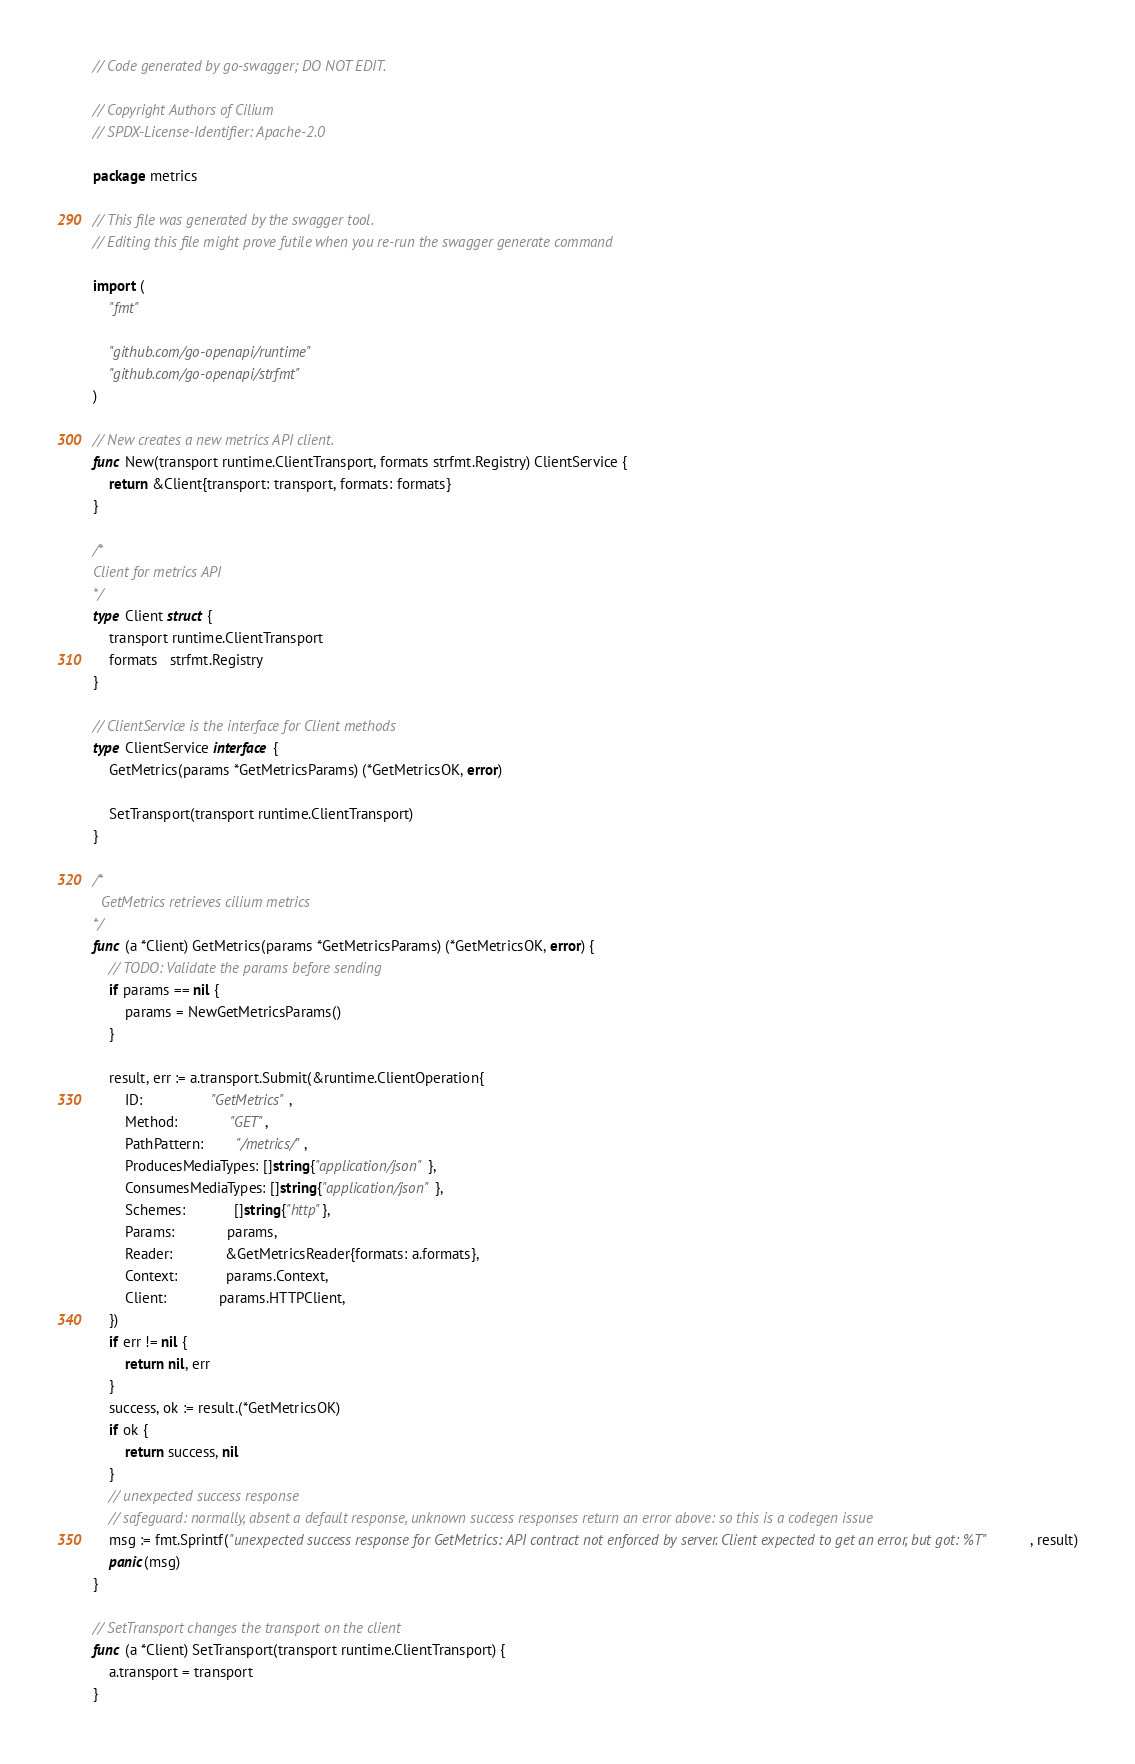Convert code to text. <code><loc_0><loc_0><loc_500><loc_500><_Go_>// Code generated by go-swagger; DO NOT EDIT.

// Copyright Authors of Cilium
// SPDX-License-Identifier: Apache-2.0

package metrics

// This file was generated by the swagger tool.
// Editing this file might prove futile when you re-run the swagger generate command

import (
	"fmt"

	"github.com/go-openapi/runtime"
	"github.com/go-openapi/strfmt"
)

// New creates a new metrics API client.
func New(transport runtime.ClientTransport, formats strfmt.Registry) ClientService {
	return &Client{transport: transport, formats: formats}
}

/*
Client for metrics API
*/
type Client struct {
	transport runtime.ClientTransport
	formats   strfmt.Registry
}

// ClientService is the interface for Client methods
type ClientService interface {
	GetMetrics(params *GetMetricsParams) (*GetMetricsOK, error)

	SetTransport(transport runtime.ClientTransport)
}

/*
  GetMetrics retrieves cilium metrics
*/
func (a *Client) GetMetrics(params *GetMetricsParams) (*GetMetricsOK, error) {
	// TODO: Validate the params before sending
	if params == nil {
		params = NewGetMetricsParams()
	}

	result, err := a.transport.Submit(&runtime.ClientOperation{
		ID:                 "GetMetrics",
		Method:             "GET",
		PathPattern:        "/metrics/",
		ProducesMediaTypes: []string{"application/json"},
		ConsumesMediaTypes: []string{"application/json"},
		Schemes:            []string{"http"},
		Params:             params,
		Reader:             &GetMetricsReader{formats: a.formats},
		Context:            params.Context,
		Client:             params.HTTPClient,
	})
	if err != nil {
		return nil, err
	}
	success, ok := result.(*GetMetricsOK)
	if ok {
		return success, nil
	}
	// unexpected success response
	// safeguard: normally, absent a default response, unknown success responses return an error above: so this is a codegen issue
	msg := fmt.Sprintf("unexpected success response for GetMetrics: API contract not enforced by server. Client expected to get an error, but got: %T", result)
	panic(msg)
}

// SetTransport changes the transport on the client
func (a *Client) SetTransport(transport runtime.ClientTransport) {
	a.transport = transport
}
</code> 